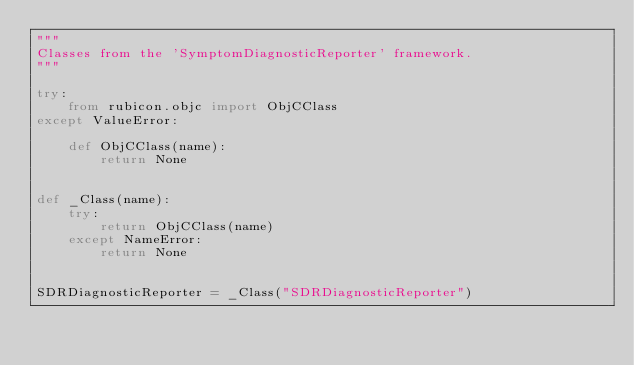Convert code to text. <code><loc_0><loc_0><loc_500><loc_500><_Python_>"""
Classes from the 'SymptomDiagnosticReporter' framework.
"""

try:
    from rubicon.objc import ObjCClass
except ValueError:

    def ObjCClass(name):
        return None


def _Class(name):
    try:
        return ObjCClass(name)
    except NameError:
        return None


SDRDiagnosticReporter = _Class("SDRDiagnosticReporter")
</code> 